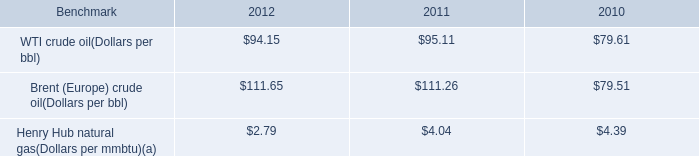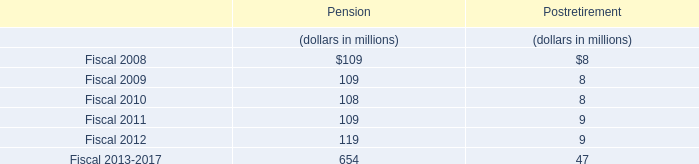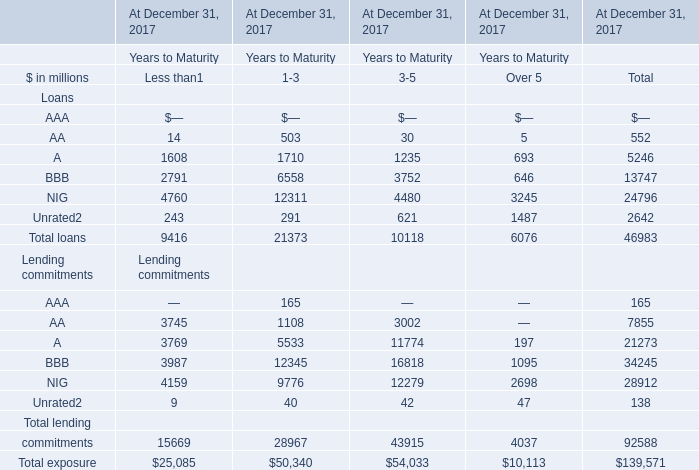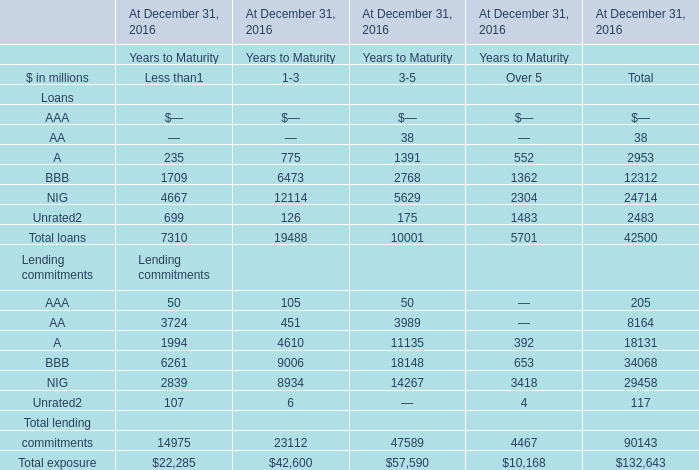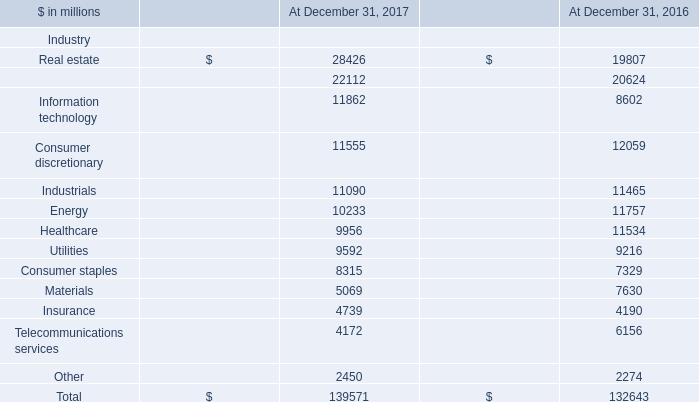What is the average amount of Consumer discretionary of At December 31, 2016, and A Loans of At December 31, 2017 Years to Maturity.1 ? 
Computations: ((12059.0 + 1710.0) / 2)
Answer: 6884.5. 